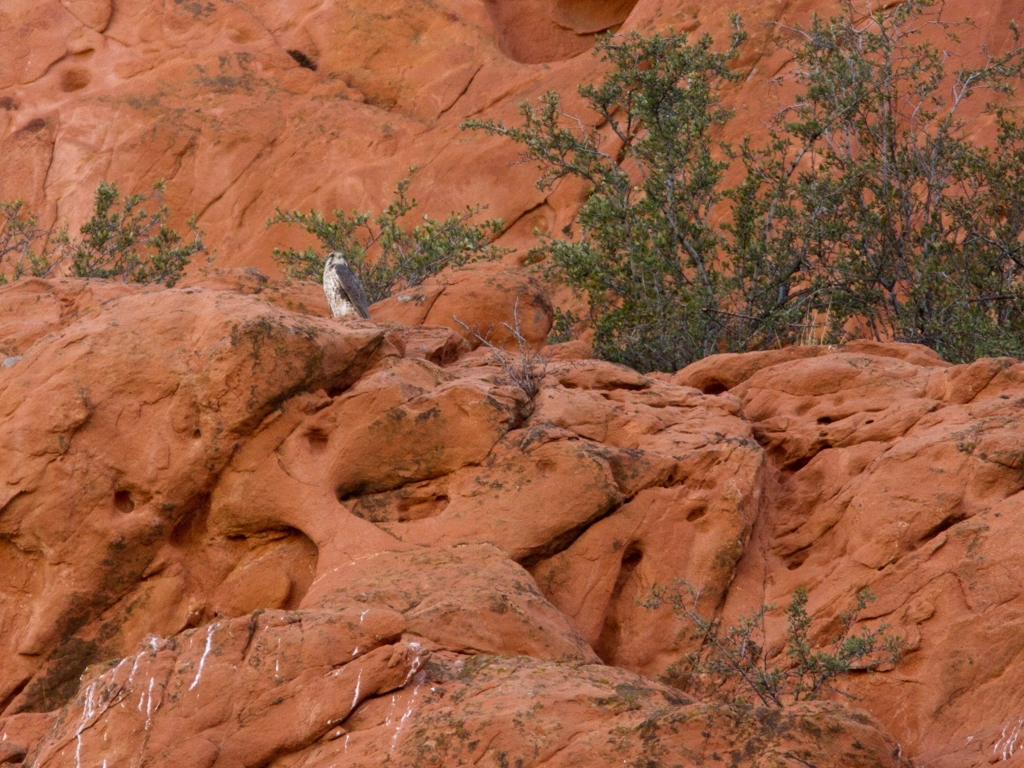Can you describe the wildlife and vegetation present in the image? Certainly. The image features a bird likely native to a rocky desert environment, perched on a sandstone formation. The vegetation is sparse, comprising small, sturdy bushes which are adapted to arid conditions, possibly species of the shrubland biome. 